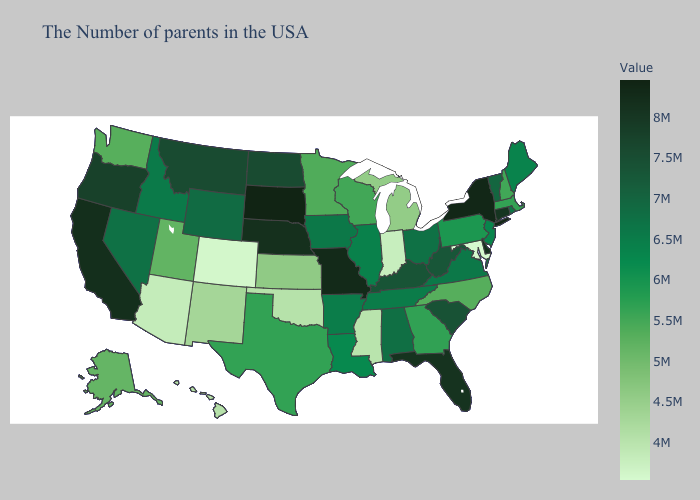Among the states that border Missouri , which have the highest value?
Concise answer only. Nebraska. Does the map have missing data?
Short answer required. No. 